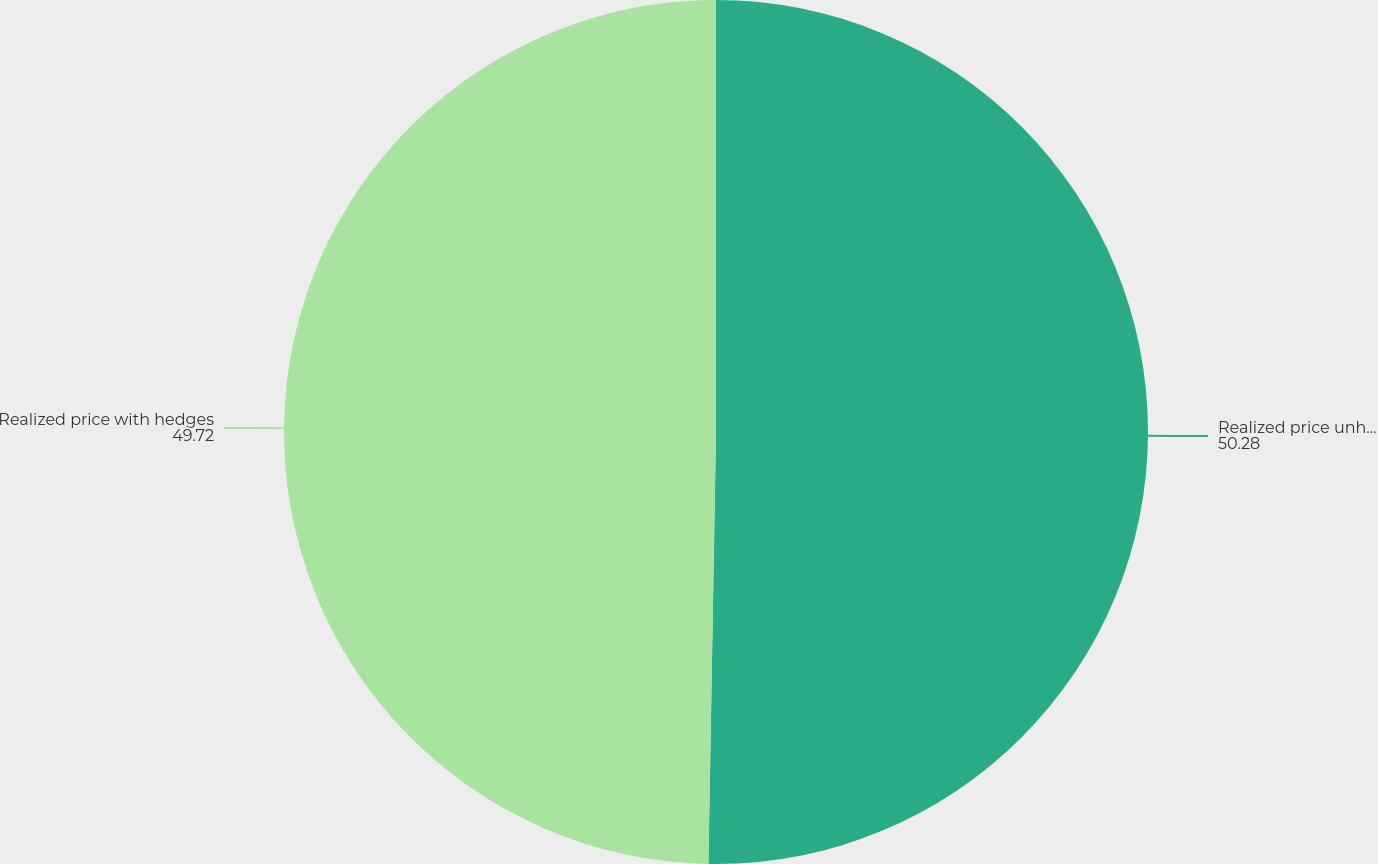<chart> <loc_0><loc_0><loc_500><loc_500><pie_chart><fcel>Realized price unhedged<fcel>Realized price with hedges<nl><fcel>50.28%<fcel>49.72%<nl></chart> 